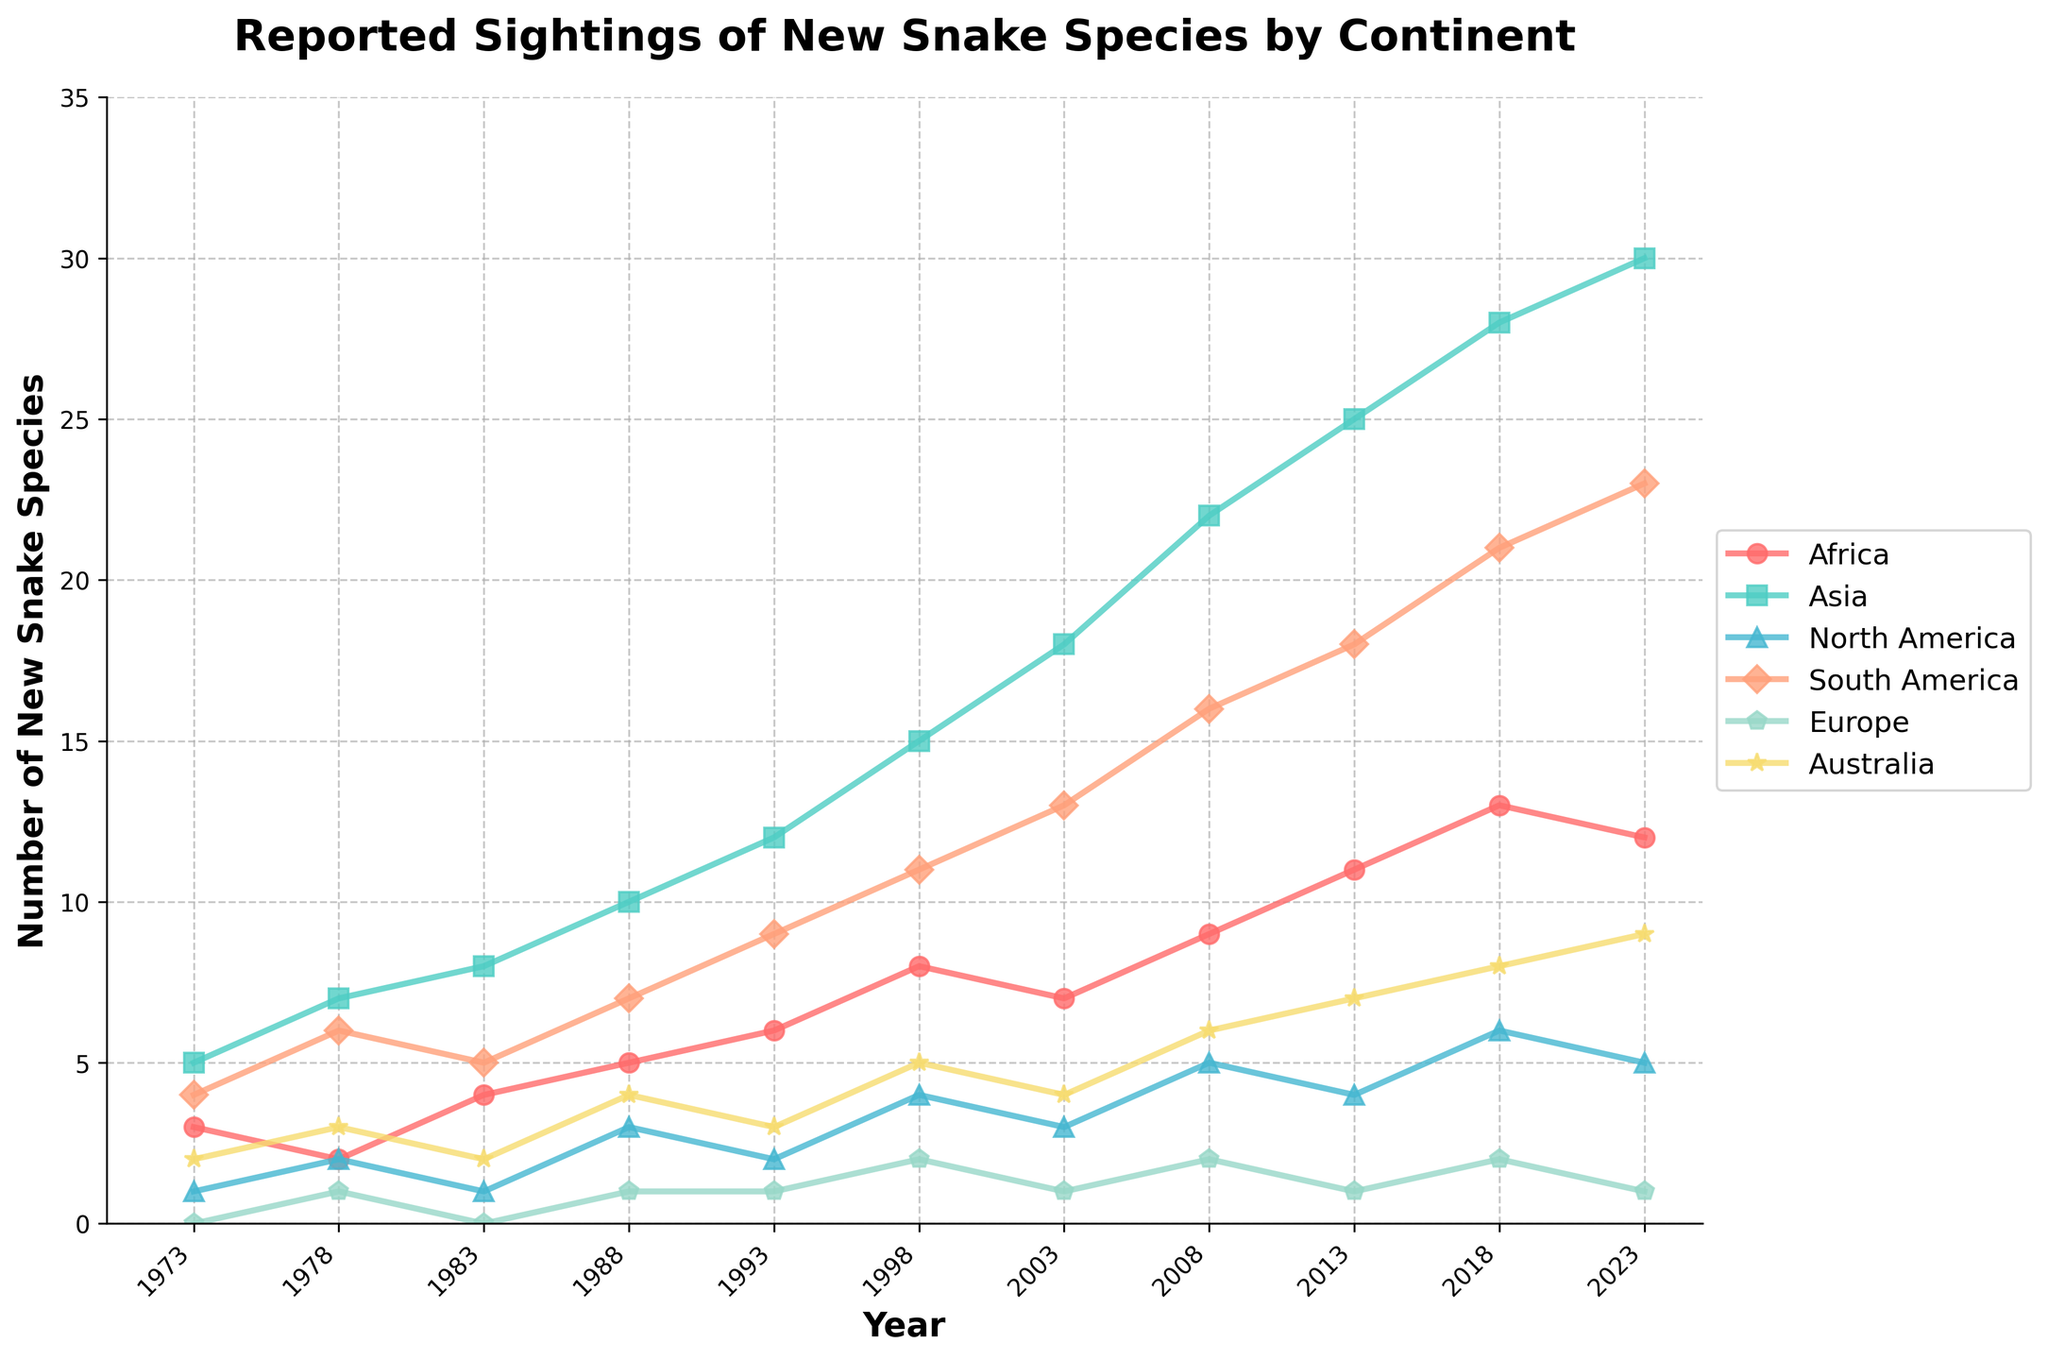What was the total number of new snake species reported in Africa and Asia in 2018? The figure shows data for Africa and Asia in 2018, which are 13 and 28 respectively. Adding these gives 13 + 28 = 41
Answer: 41 Across which year did Asia see a notable increase in reported new snake species compared to the previous year? Comparing the reported sightings in Asia year by year, the largest increase is between 1998 (15) and 2003 (18), an increase of 3 species
Answer: 2003 Which continent had the lowest number of new snake species reported in 2013? Checking the reported sightings for 2013, the numbers are Africa (11), Asia (25), North America (4), South America (18), Europe (1), and Australia (7). The lowest number is 1 (Europe)
Answer: Europe By how much did the number of new snake species reported in South America change from 1988 to 1993? In 1988, 7 new species were reported in South America and in 1993 the number was 9. The change is 9 - 7 = 2
Answer: 2 Which continent saw a consistent increase in the number of reported new snake species over the entire period? Observing the trends, Asia shows a steady increase in reported species from 5 in 1973 to 30 in 2023
Answer: Asia What is the average number of new snake species reported in Australia over the years 1983, 1988, and 1993? The reported sightings for Australia in the specified years are 2 (1983), 4 (1988), and 3 (1993). Adding these values gives 2 + 4 + 3 = 9. The average is 9/3 = 3
Answer: 3 Which continent had a larger increase in reported new species from 2013 to 2018, North America or Europe? Checking the numbers, North America’s sightings increased from 4 to 6 (2 species), while Europe’s sightings increased from 1 to 2 (1 species). So, North America had a larger increase
Answer: North America In which two consecutive years did Africa experience the largest increase in new snake species reports? Comparing year-by-year differences for Africa, the largest increase is between 1998 (8) and 2003 (7), an increase of 1. The largest significant visual jump that stands out is from 2008 (9) to 2013 (11) increasing by 2
Answer: 2008 - 2013 Did South America ever report the same number of new snake species in two different years? By scanning through South America's data, all the numbers for each year are unique: 4, 6, 5, 7, 9, 11, 13, 16, 18, 21, 23. No repetition is observed
Answer: No 